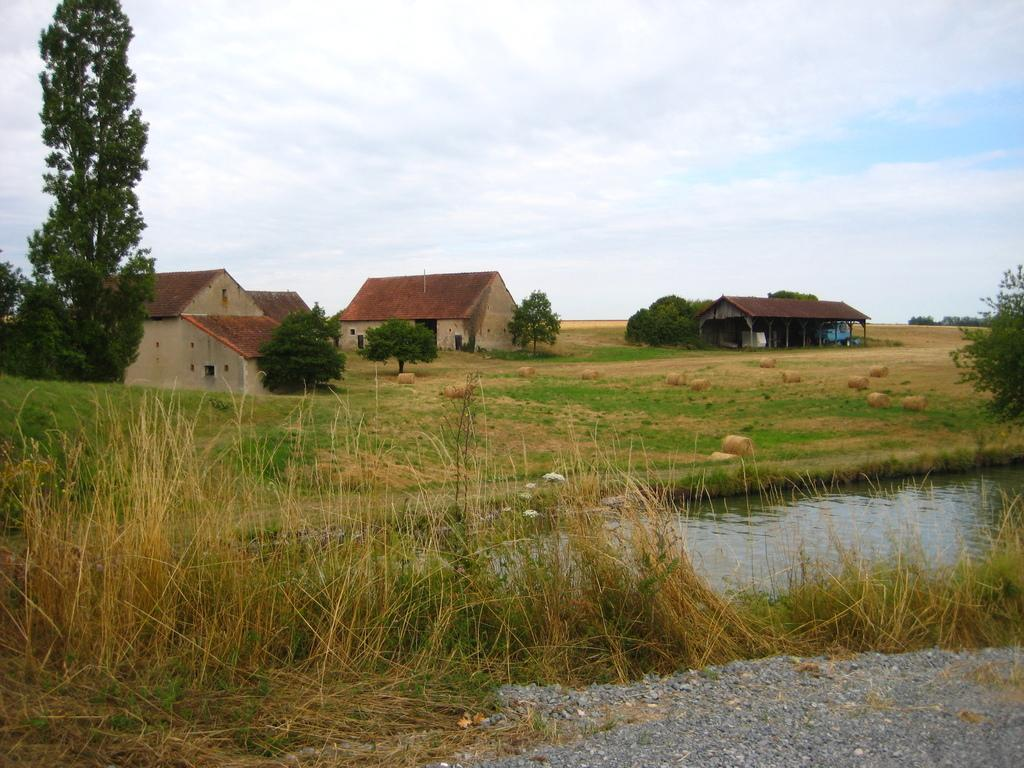What is present at the bottom of the image? There are small stones, grass, and water visible at the bottom of the image. What can be seen in the background of the image? There are trees, houses, roofs, a vehicle, and grass on the ground in the background of the image. What is visible in the sky? There are clouds visible in the sky. What type of music can be heard playing in the background of the image? There is no music present in the image, as it is a visual representation and does not include sound. Is there an earth-like planet visible in the image? The image does not depict any planets or celestial bodies; it is a landscape featuring small stones, grass, water, trees, houses, roofs, a vehicle, and clouds. 